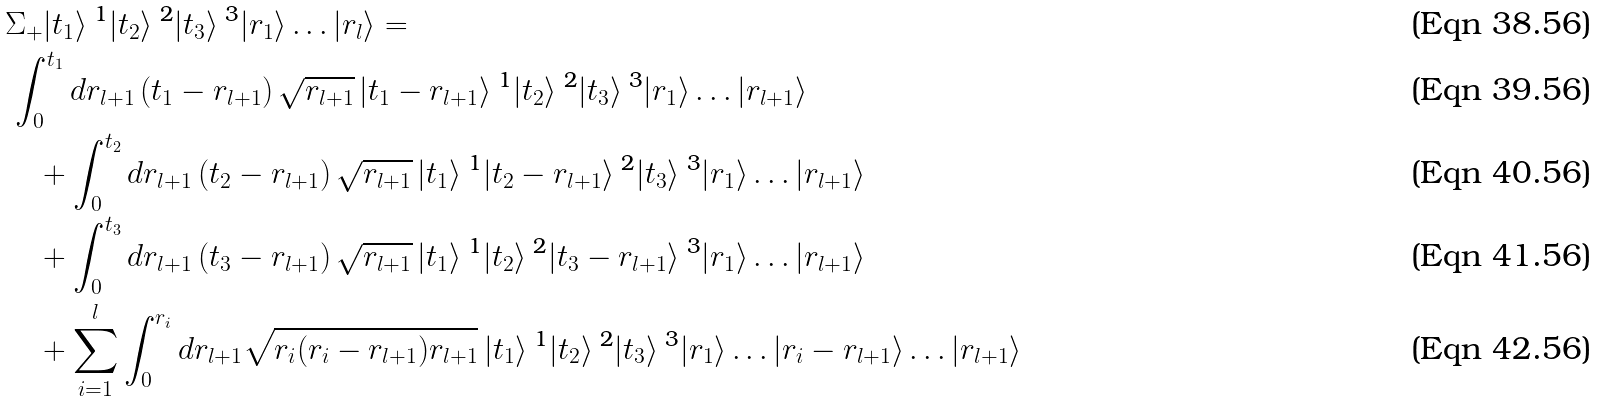Convert formula to latex. <formula><loc_0><loc_0><loc_500><loc_500>& \Sigma _ { + } | t _ { 1 } \rangle ^ { \text { 1} } | t _ { 2 } \rangle ^ { \text { 2} } | t _ { 3 } \rangle ^ { \text { 3} } | r _ { 1 } \rangle \dots | r _ { l } \rangle = \\ & \, \int _ { 0 } ^ { t _ { 1 } } d r _ { l + 1 } \left ( t _ { 1 } - r _ { l + 1 } \right ) \sqrt { r _ { l + 1 } } \, | t _ { 1 } - r _ { l + 1 } \rangle ^ { \text { 1} } | t _ { 2 } \rangle ^ { \text { 2} } | t _ { 3 } \rangle ^ { \text { 3} } | r _ { 1 } \rangle \dots | r _ { l + 1 } \rangle \\ & \quad + \int _ { 0 } ^ { t _ { 2 } } d r _ { l + 1 } \left ( t _ { 2 } - r _ { l + 1 } \right ) \sqrt { r _ { l + 1 } } \, | t _ { 1 } \rangle ^ { \text { 1} } | t _ { 2 } - r _ { l + 1 } \rangle ^ { \text { 2} } | t _ { 3 } \rangle ^ { \text { 3} } | r _ { 1 } \rangle \dots | r _ { l + 1 } \rangle \\ & \quad + \int _ { 0 } ^ { t _ { 3 } } d r _ { l + 1 } \left ( t _ { 3 } - r _ { l + 1 } \right ) \sqrt { r _ { l + 1 } } \, | t _ { 1 } \rangle ^ { \text { 1} } | t _ { 2 } \rangle ^ { \text { 2} } | t _ { 3 } - r _ { l + 1 } \rangle ^ { \text { 3} } | r _ { 1 } \rangle \dots | r _ { l + 1 } \rangle \\ & \quad + \sum _ { i = 1 } ^ { l } \int _ { 0 } ^ { r _ { i } } d r _ { l + 1 } \sqrt { r _ { i } ( r _ { i } - r _ { l + 1 } ) r _ { l + 1 } } \, | t _ { 1 } \rangle ^ { \text { 1} } | t _ { 2 } \rangle ^ { \text { 2} } | t _ { 3 } \rangle ^ { \text { 3} } | r _ { 1 } \rangle \dots | r _ { i } - r _ { l + 1 } \rangle \dots | r _ { l + 1 } \rangle</formula> 